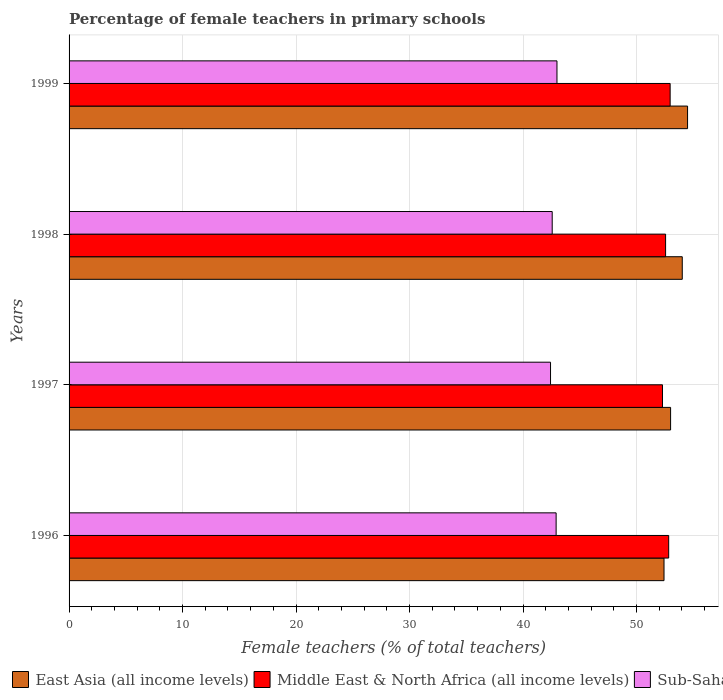How many different coloured bars are there?
Ensure brevity in your answer.  3. Are the number of bars per tick equal to the number of legend labels?
Offer a terse response. Yes. Are the number of bars on each tick of the Y-axis equal?
Give a very brief answer. Yes. What is the label of the 1st group of bars from the top?
Offer a terse response. 1999. What is the percentage of female teachers in East Asia (all income levels) in 1996?
Provide a succinct answer. 52.43. Across all years, what is the maximum percentage of female teachers in East Asia (all income levels)?
Offer a very short reply. 54.5. Across all years, what is the minimum percentage of female teachers in East Asia (all income levels)?
Make the answer very short. 52.43. In which year was the percentage of female teachers in Sub-Saharan Africa (all income levels) maximum?
Provide a succinct answer. 1999. In which year was the percentage of female teachers in East Asia (all income levels) minimum?
Your answer should be compact. 1996. What is the total percentage of female teachers in Sub-Saharan Africa (all income levels) in the graph?
Offer a very short reply. 170.91. What is the difference between the percentage of female teachers in East Asia (all income levels) in 1996 and that in 1998?
Your answer should be very brief. -1.61. What is the difference between the percentage of female teachers in East Asia (all income levels) in 1997 and the percentage of female teachers in Middle East & North Africa (all income levels) in 1999?
Make the answer very short. 0.04. What is the average percentage of female teachers in Middle East & North Africa (all income levels) per year?
Give a very brief answer. 52.67. In the year 1999, what is the difference between the percentage of female teachers in East Asia (all income levels) and percentage of female teachers in Middle East & North Africa (all income levels)?
Provide a succinct answer. 1.54. What is the ratio of the percentage of female teachers in Middle East & North Africa (all income levels) in 1996 to that in 1999?
Provide a succinct answer. 1. What is the difference between the highest and the second highest percentage of female teachers in Sub-Saharan Africa (all income levels)?
Your answer should be compact. 0.07. What is the difference between the highest and the lowest percentage of female teachers in East Asia (all income levels)?
Provide a short and direct response. 2.07. Is the sum of the percentage of female teachers in Middle East & North Africa (all income levels) in 1998 and 1999 greater than the maximum percentage of female teachers in East Asia (all income levels) across all years?
Offer a very short reply. Yes. What does the 1st bar from the top in 1998 represents?
Ensure brevity in your answer.  Sub-Saharan Africa (all income levels). What does the 2nd bar from the bottom in 1997 represents?
Offer a terse response. Middle East & North Africa (all income levels). Is it the case that in every year, the sum of the percentage of female teachers in Middle East & North Africa (all income levels) and percentage of female teachers in East Asia (all income levels) is greater than the percentage of female teachers in Sub-Saharan Africa (all income levels)?
Give a very brief answer. Yes. How many bars are there?
Make the answer very short. 12. Are all the bars in the graph horizontal?
Provide a short and direct response. Yes. Does the graph contain any zero values?
Offer a very short reply. No. Where does the legend appear in the graph?
Your answer should be compact. Bottom left. How many legend labels are there?
Your answer should be compact. 3. How are the legend labels stacked?
Offer a terse response. Horizontal. What is the title of the graph?
Provide a succinct answer. Percentage of female teachers in primary schools. What is the label or title of the X-axis?
Your answer should be very brief. Female teachers (% of total teachers). What is the label or title of the Y-axis?
Provide a short and direct response. Years. What is the Female teachers (% of total teachers) of East Asia (all income levels) in 1996?
Make the answer very short. 52.43. What is the Female teachers (% of total teachers) of Middle East & North Africa (all income levels) in 1996?
Keep it short and to the point. 52.84. What is the Female teachers (% of total teachers) of Sub-Saharan Africa (all income levels) in 1996?
Provide a short and direct response. 42.92. What is the Female teachers (% of total teachers) in East Asia (all income levels) in 1997?
Ensure brevity in your answer.  53.01. What is the Female teachers (% of total teachers) in Middle East & North Africa (all income levels) in 1997?
Your response must be concise. 52.29. What is the Female teachers (% of total teachers) in Sub-Saharan Africa (all income levels) in 1997?
Offer a terse response. 42.43. What is the Female teachers (% of total teachers) in East Asia (all income levels) in 1998?
Make the answer very short. 54.03. What is the Female teachers (% of total teachers) of Middle East & North Africa (all income levels) in 1998?
Your response must be concise. 52.56. What is the Female teachers (% of total teachers) in Sub-Saharan Africa (all income levels) in 1998?
Your answer should be compact. 42.57. What is the Female teachers (% of total teachers) in East Asia (all income levels) in 1999?
Offer a very short reply. 54.5. What is the Female teachers (% of total teachers) of Middle East & North Africa (all income levels) in 1999?
Your response must be concise. 52.97. What is the Female teachers (% of total teachers) of Sub-Saharan Africa (all income levels) in 1999?
Make the answer very short. 42.99. Across all years, what is the maximum Female teachers (% of total teachers) of East Asia (all income levels)?
Keep it short and to the point. 54.5. Across all years, what is the maximum Female teachers (% of total teachers) in Middle East & North Africa (all income levels)?
Your answer should be compact. 52.97. Across all years, what is the maximum Female teachers (% of total teachers) of Sub-Saharan Africa (all income levels)?
Provide a short and direct response. 42.99. Across all years, what is the minimum Female teachers (% of total teachers) in East Asia (all income levels)?
Offer a very short reply. 52.43. Across all years, what is the minimum Female teachers (% of total teachers) in Middle East & North Africa (all income levels)?
Make the answer very short. 52.29. Across all years, what is the minimum Female teachers (% of total teachers) of Sub-Saharan Africa (all income levels)?
Your answer should be compact. 42.43. What is the total Female teachers (% of total teachers) in East Asia (all income levels) in the graph?
Your answer should be very brief. 213.97. What is the total Female teachers (% of total teachers) in Middle East & North Africa (all income levels) in the graph?
Make the answer very short. 210.66. What is the total Female teachers (% of total teachers) of Sub-Saharan Africa (all income levels) in the graph?
Your response must be concise. 170.91. What is the difference between the Female teachers (% of total teachers) of East Asia (all income levels) in 1996 and that in 1997?
Your answer should be compact. -0.58. What is the difference between the Female teachers (% of total teachers) of Middle East & North Africa (all income levels) in 1996 and that in 1997?
Give a very brief answer. 0.55. What is the difference between the Female teachers (% of total teachers) of Sub-Saharan Africa (all income levels) in 1996 and that in 1997?
Keep it short and to the point. 0.49. What is the difference between the Female teachers (% of total teachers) in East Asia (all income levels) in 1996 and that in 1998?
Your answer should be compact. -1.61. What is the difference between the Female teachers (% of total teachers) of Middle East & North Africa (all income levels) in 1996 and that in 1998?
Your answer should be compact. 0.27. What is the difference between the Female teachers (% of total teachers) of Sub-Saharan Africa (all income levels) in 1996 and that in 1998?
Your response must be concise. 0.35. What is the difference between the Female teachers (% of total teachers) of East Asia (all income levels) in 1996 and that in 1999?
Keep it short and to the point. -2.08. What is the difference between the Female teachers (% of total teachers) in Middle East & North Africa (all income levels) in 1996 and that in 1999?
Offer a very short reply. -0.13. What is the difference between the Female teachers (% of total teachers) in Sub-Saharan Africa (all income levels) in 1996 and that in 1999?
Give a very brief answer. -0.07. What is the difference between the Female teachers (% of total teachers) in East Asia (all income levels) in 1997 and that in 1998?
Provide a short and direct response. -1.03. What is the difference between the Female teachers (% of total teachers) in Middle East & North Africa (all income levels) in 1997 and that in 1998?
Provide a short and direct response. -0.27. What is the difference between the Female teachers (% of total teachers) in Sub-Saharan Africa (all income levels) in 1997 and that in 1998?
Offer a very short reply. -0.15. What is the difference between the Female teachers (% of total teachers) of East Asia (all income levels) in 1997 and that in 1999?
Offer a terse response. -1.5. What is the difference between the Female teachers (% of total teachers) of Middle East & North Africa (all income levels) in 1997 and that in 1999?
Your answer should be compact. -0.68. What is the difference between the Female teachers (% of total teachers) of Sub-Saharan Africa (all income levels) in 1997 and that in 1999?
Your answer should be compact. -0.57. What is the difference between the Female teachers (% of total teachers) of East Asia (all income levels) in 1998 and that in 1999?
Provide a succinct answer. -0.47. What is the difference between the Female teachers (% of total teachers) in Middle East & North Africa (all income levels) in 1998 and that in 1999?
Provide a short and direct response. -0.4. What is the difference between the Female teachers (% of total teachers) of Sub-Saharan Africa (all income levels) in 1998 and that in 1999?
Give a very brief answer. -0.42. What is the difference between the Female teachers (% of total teachers) in East Asia (all income levels) in 1996 and the Female teachers (% of total teachers) in Middle East & North Africa (all income levels) in 1997?
Offer a terse response. 0.14. What is the difference between the Female teachers (% of total teachers) in East Asia (all income levels) in 1996 and the Female teachers (% of total teachers) in Sub-Saharan Africa (all income levels) in 1997?
Offer a very short reply. 10. What is the difference between the Female teachers (% of total teachers) in Middle East & North Africa (all income levels) in 1996 and the Female teachers (% of total teachers) in Sub-Saharan Africa (all income levels) in 1997?
Offer a very short reply. 10.41. What is the difference between the Female teachers (% of total teachers) of East Asia (all income levels) in 1996 and the Female teachers (% of total teachers) of Middle East & North Africa (all income levels) in 1998?
Your response must be concise. -0.14. What is the difference between the Female teachers (% of total teachers) in East Asia (all income levels) in 1996 and the Female teachers (% of total teachers) in Sub-Saharan Africa (all income levels) in 1998?
Provide a succinct answer. 9.85. What is the difference between the Female teachers (% of total teachers) of Middle East & North Africa (all income levels) in 1996 and the Female teachers (% of total teachers) of Sub-Saharan Africa (all income levels) in 1998?
Provide a succinct answer. 10.26. What is the difference between the Female teachers (% of total teachers) of East Asia (all income levels) in 1996 and the Female teachers (% of total teachers) of Middle East & North Africa (all income levels) in 1999?
Provide a succinct answer. -0.54. What is the difference between the Female teachers (% of total teachers) of East Asia (all income levels) in 1996 and the Female teachers (% of total teachers) of Sub-Saharan Africa (all income levels) in 1999?
Your response must be concise. 9.43. What is the difference between the Female teachers (% of total teachers) of Middle East & North Africa (all income levels) in 1996 and the Female teachers (% of total teachers) of Sub-Saharan Africa (all income levels) in 1999?
Your response must be concise. 9.85. What is the difference between the Female teachers (% of total teachers) in East Asia (all income levels) in 1997 and the Female teachers (% of total teachers) in Middle East & North Africa (all income levels) in 1998?
Give a very brief answer. 0.44. What is the difference between the Female teachers (% of total teachers) of East Asia (all income levels) in 1997 and the Female teachers (% of total teachers) of Sub-Saharan Africa (all income levels) in 1998?
Keep it short and to the point. 10.43. What is the difference between the Female teachers (% of total teachers) in Middle East & North Africa (all income levels) in 1997 and the Female teachers (% of total teachers) in Sub-Saharan Africa (all income levels) in 1998?
Your answer should be compact. 9.72. What is the difference between the Female teachers (% of total teachers) of East Asia (all income levels) in 1997 and the Female teachers (% of total teachers) of Middle East & North Africa (all income levels) in 1999?
Offer a terse response. 0.04. What is the difference between the Female teachers (% of total teachers) in East Asia (all income levels) in 1997 and the Female teachers (% of total teachers) in Sub-Saharan Africa (all income levels) in 1999?
Your response must be concise. 10.01. What is the difference between the Female teachers (% of total teachers) in Middle East & North Africa (all income levels) in 1997 and the Female teachers (% of total teachers) in Sub-Saharan Africa (all income levels) in 1999?
Provide a succinct answer. 9.3. What is the difference between the Female teachers (% of total teachers) in East Asia (all income levels) in 1998 and the Female teachers (% of total teachers) in Middle East & North Africa (all income levels) in 1999?
Keep it short and to the point. 1.07. What is the difference between the Female teachers (% of total teachers) in East Asia (all income levels) in 1998 and the Female teachers (% of total teachers) in Sub-Saharan Africa (all income levels) in 1999?
Keep it short and to the point. 11.04. What is the difference between the Female teachers (% of total teachers) in Middle East & North Africa (all income levels) in 1998 and the Female teachers (% of total teachers) in Sub-Saharan Africa (all income levels) in 1999?
Give a very brief answer. 9.57. What is the average Female teachers (% of total teachers) of East Asia (all income levels) per year?
Offer a terse response. 53.49. What is the average Female teachers (% of total teachers) of Middle East & North Africa (all income levels) per year?
Your answer should be compact. 52.67. What is the average Female teachers (% of total teachers) in Sub-Saharan Africa (all income levels) per year?
Give a very brief answer. 42.73. In the year 1996, what is the difference between the Female teachers (% of total teachers) of East Asia (all income levels) and Female teachers (% of total teachers) of Middle East & North Africa (all income levels)?
Provide a succinct answer. -0.41. In the year 1996, what is the difference between the Female teachers (% of total teachers) of East Asia (all income levels) and Female teachers (% of total teachers) of Sub-Saharan Africa (all income levels)?
Ensure brevity in your answer.  9.51. In the year 1996, what is the difference between the Female teachers (% of total teachers) in Middle East & North Africa (all income levels) and Female teachers (% of total teachers) in Sub-Saharan Africa (all income levels)?
Your response must be concise. 9.92. In the year 1997, what is the difference between the Female teachers (% of total teachers) in East Asia (all income levels) and Female teachers (% of total teachers) in Middle East & North Africa (all income levels)?
Offer a terse response. 0.71. In the year 1997, what is the difference between the Female teachers (% of total teachers) in East Asia (all income levels) and Female teachers (% of total teachers) in Sub-Saharan Africa (all income levels)?
Offer a very short reply. 10.58. In the year 1997, what is the difference between the Female teachers (% of total teachers) of Middle East & North Africa (all income levels) and Female teachers (% of total teachers) of Sub-Saharan Africa (all income levels)?
Provide a succinct answer. 9.87. In the year 1998, what is the difference between the Female teachers (% of total teachers) in East Asia (all income levels) and Female teachers (% of total teachers) in Middle East & North Africa (all income levels)?
Your answer should be compact. 1.47. In the year 1998, what is the difference between the Female teachers (% of total teachers) of East Asia (all income levels) and Female teachers (% of total teachers) of Sub-Saharan Africa (all income levels)?
Offer a terse response. 11.46. In the year 1998, what is the difference between the Female teachers (% of total teachers) of Middle East & North Africa (all income levels) and Female teachers (% of total teachers) of Sub-Saharan Africa (all income levels)?
Offer a terse response. 9.99. In the year 1999, what is the difference between the Female teachers (% of total teachers) in East Asia (all income levels) and Female teachers (% of total teachers) in Middle East & North Africa (all income levels)?
Ensure brevity in your answer.  1.54. In the year 1999, what is the difference between the Female teachers (% of total teachers) in East Asia (all income levels) and Female teachers (% of total teachers) in Sub-Saharan Africa (all income levels)?
Keep it short and to the point. 11.51. In the year 1999, what is the difference between the Female teachers (% of total teachers) in Middle East & North Africa (all income levels) and Female teachers (% of total teachers) in Sub-Saharan Africa (all income levels)?
Your response must be concise. 9.97. What is the ratio of the Female teachers (% of total teachers) of Middle East & North Africa (all income levels) in 1996 to that in 1997?
Your response must be concise. 1.01. What is the ratio of the Female teachers (% of total teachers) in Sub-Saharan Africa (all income levels) in 1996 to that in 1997?
Provide a succinct answer. 1.01. What is the ratio of the Female teachers (% of total teachers) in East Asia (all income levels) in 1996 to that in 1998?
Give a very brief answer. 0.97. What is the ratio of the Female teachers (% of total teachers) in East Asia (all income levels) in 1996 to that in 1999?
Offer a terse response. 0.96. What is the ratio of the Female teachers (% of total teachers) of Middle East & North Africa (all income levels) in 1996 to that in 1999?
Your answer should be very brief. 1. What is the ratio of the Female teachers (% of total teachers) in East Asia (all income levels) in 1997 to that in 1998?
Provide a short and direct response. 0.98. What is the ratio of the Female teachers (% of total teachers) of Middle East & North Africa (all income levels) in 1997 to that in 1998?
Keep it short and to the point. 0.99. What is the ratio of the Female teachers (% of total teachers) in Sub-Saharan Africa (all income levels) in 1997 to that in 1998?
Your answer should be compact. 1. What is the ratio of the Female teachers (% of total teachers) of East Asia (all income levels) in 1997 to that in 1999?
Offer a very short reply. 0.97. What is the ratio of the Female teachers (% of total teachers) of Middle East & North Africa (all income levels) in 1997 to that in 1999?
Give a very brief answer. 0.99. What is the ratio of the Female teachers (% of total teachers) of Sub-Saharan Africa (all income levels) in 1997 to that in 1999?
Offer a very short reply. 0.99. What is the ratio of the Female teachers (% of total teachers) in Sub-Saharan Africa (all income levels) in 1998 to that in 1999?
Offer a very short reply. 0.99. What is the difference between the highest and the second highest Female teachers (% of total teachers) of East Asia (all income levels)?
Provide a short and direct response. 0.47. What is the difference between the highest and the second highest Female teachers (% of total teachers) of Middle East & North Africa (all income levels)?
Make the answer very short. 0.13. What is the difference between the highest and the second highest Female teachers (% of total teachers) in Sub-Saharan Africa (all income levels)?
Keep it short and to the point. 0.07. What is the difference between the highest and the lowest Female teachers (% of total teachers) in East Asia (all income levels)?
Your answer should be very brief. 2.08. What is the difference between the highest and the lowest Female teachers (% of total teachers) of Middle East & North Africa (all income levels)?
Your response must be concise. 0.68. What is the difference between the highest and the lowest Female teachers (% of total teachers) of Sub-Saharan Africa (all income levels)?
Ensure brevity in your answer.  0.57. 